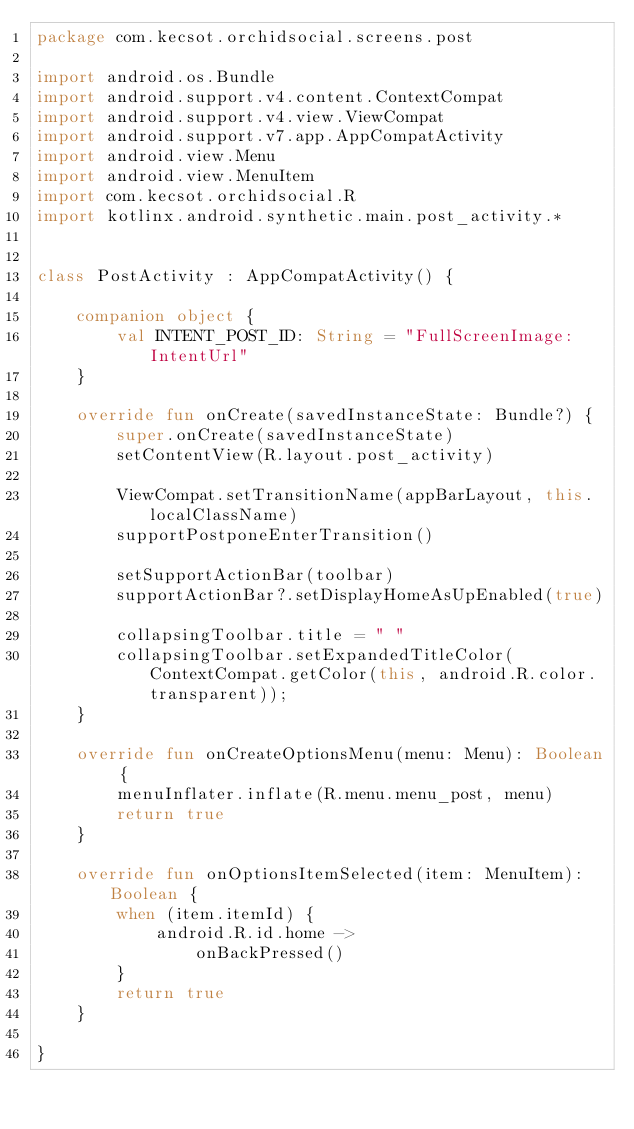Convert code to text. <code><loc_0><loc_0><loc_500><loc_500><_Kotlin_>package com.kecsot.orchidsocial.screens.post

import android.os.Bundle
import android.support.v4.content.ContextCompat
import android.support.v4.view.ViewCompat
import android.support.v7.app.AppCompatActivity
import android.view.Menu
import android.view.MenuItem
import com.kecsot.orchidsocial.R
import kotlinx.android.synthetic.main.post_activity.*


class PostActivity : AppCompatActivity() {

    companion object {
        val INTENT_POST_ID: String = "FullScreenImage:IntentUrl"
    }

    override fun onCreate(savedInstanceState: Bundle?) {
        super.onCreate(savedInstanceState)
        setContentView(R.layout.post_activity)

        ViewCompat.setTransitionName(appBarLayout, this.localClassName)
        supportPostponeEnterTransition()

        setSupportActionBar(toolbar)
        supportActionBar?.setDisplayHomeAsUpEnabled(true)

        collapsingToolbar.title = " "
        collapsingToolbar.setExpandedTitleColor(ContextCompat.getColor(this, android.R.color.transparent));
    }

    override fun onCreateOptionsMenu(menu: Menu): Boolean {
        menuInflater.inflate(R.menu.menu_post, menu)
        return true
    }

    override fun onOptionsItemSelected(item: MenuItem): Boolean {
        when (item.itemId) {
            android.R.id.home ->
                onBackPressed()
        }
        return true
    }

}
</code> 